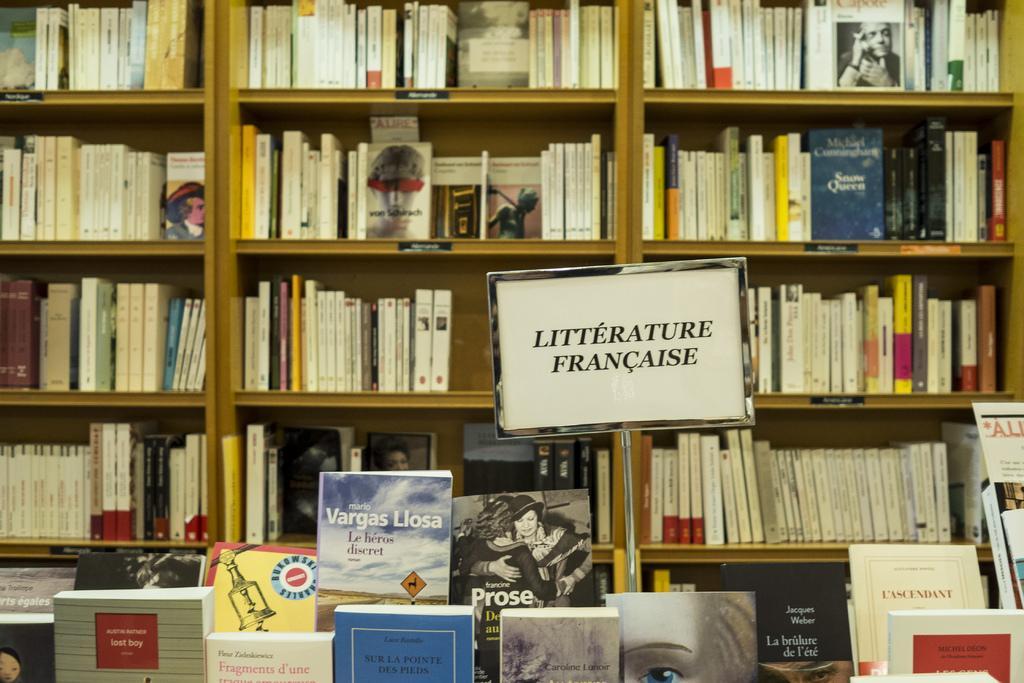Can you describe this image briefly? In this image we can see books in a bookshelf. There is a board with some text. At the bottom of the image there are books. 